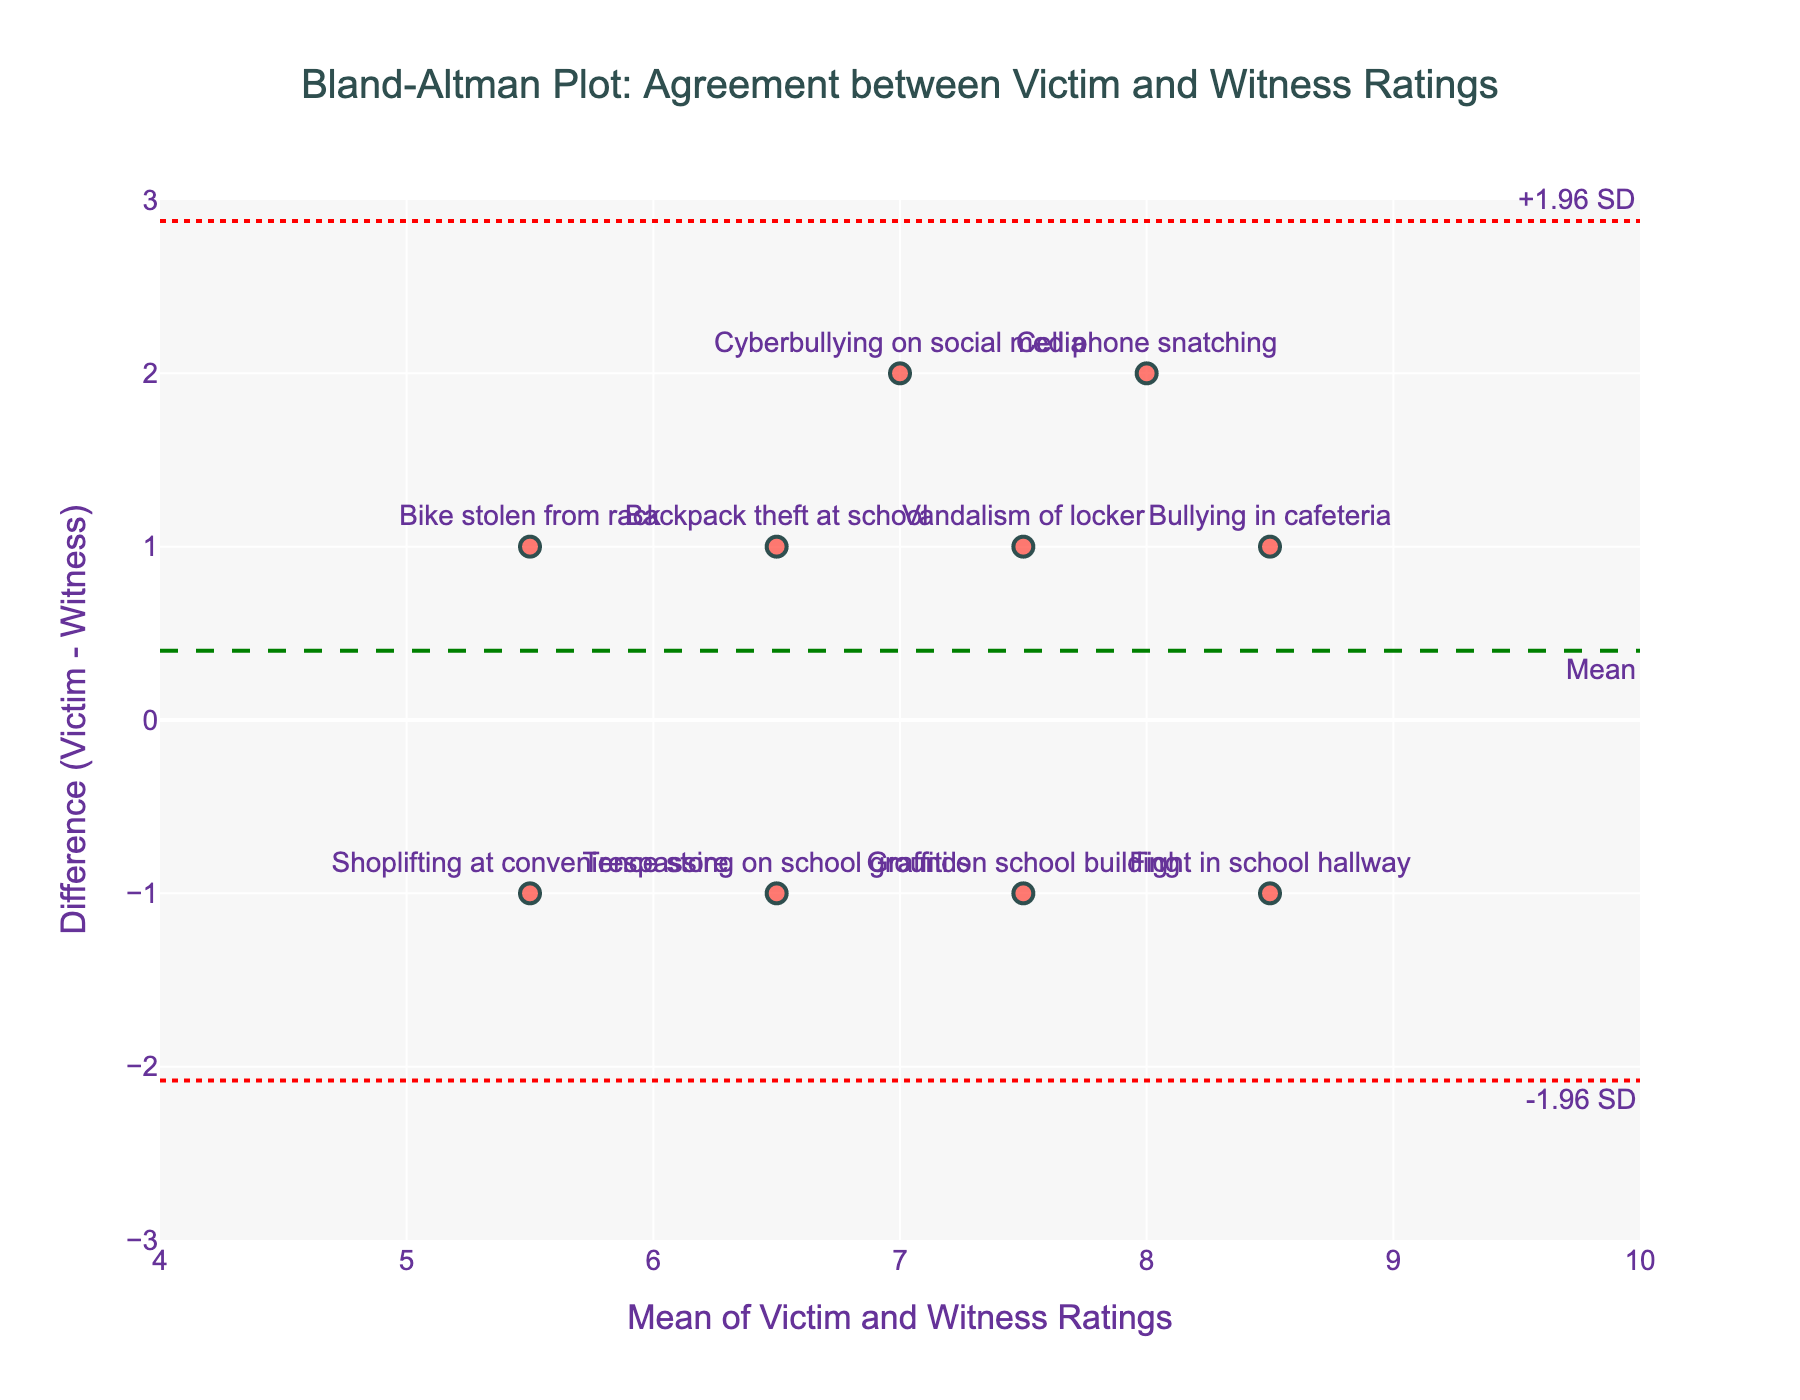What is the title of the plot? The title of a plot is typically located at the top of the figure and provides a brief description of the content it represents. In this case, the title is "Bland-Altman Plot: Agreement between Victim and Witness Ratings".
Answer: Bland-Altman Plot: Agreement between Victim and Witness Ratings How many incidents are plotted? Each incident corresponds to one marker on the plot. By counting the number of markers, we can determine the number of incidents plotted.
Answer: 10 What is the mean of the victim and witness ratings for the "Bullying in cafeteria" incident? The mean is calculated as (Victim_Rating + Witness_Rating) / 2. For "Bullying in cafeteria", the ratings are 9 and 8, respectively, so the mean is (9 + 8) / 2 = 8.5.
Answer: 8.5 Which incident has the largest difference between victim and witness ratings? By examining the vertical position of the markers, we can identify which one is furthest from the horizontal axis. "Cyberbullying on social media" has the largest negative difference, indicating the largest discrepancy.
Answer: Cyberbullying on social media What are the limits of agreement on the plot? The limits of agreement are given by the mean difference ± 1.96 times the standard deviation of the differences. These limits are represented by the dotted red lines.
Answer: -1.96 to 1.96 What is the difference between the victim and witness ratings for "Shoplifting at convenience store"? The difference is calculated as Victim_Rating - Witness_Rating. For "Shoplifting at convenience store", the ratings are 5 and 6, respectively, so the difference is 5 - 6 = -1.
Answer: -1 Which incident's mean rating is closest to the mean line? The mean line (green dashed line) represents the average of the differences. By observing the markers, "Fight in school hallway" appears closest to the mean line.
Answer: Fight in school hallway How does the amount of agreement vary across the range of mean ratings? By observing the spread of the markers from the mean line, we see that incidents with higher mean ratings tend to have smaller differences, indicating greater agreement.
Answer: Greater agreement at higher mean ratings What's the value of the maximum positive difference shown on the plot? The maximum positive difference is the highest point above the horizontal axis. Referring to the y-axis, the maximum positive difference is +2.
Answer: 2 Which incidents lie outside the limits of agreement? Incidents lying outside the dotted red lines are outside the limits of agreement. "Cyberbullying on social media" and "Cell phone snatching" fall outside these limits.
Answer: Cyberbullying on social media, Cell phone snatching 